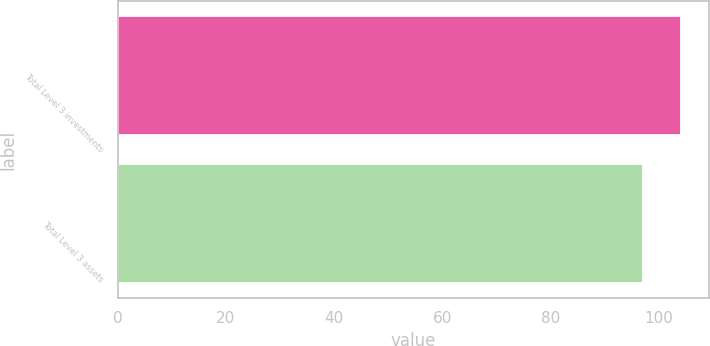Convert chart to OTSL. <chart><loc_0><loc_0><loc_500><loc_500><bar_chart><fcel>Total Level 3 investments<fcel>Total Level 3 assets<nl><fcel>104<fcel>97<nl></chart> 